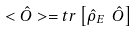Convert formula to latex. <formula><loc_0><loc_0><loc_500><loc_500>< \hat { O } > = t r \left [ { \hat { \rho } } _ { E } \ \hat { O } \right ]</formula> 